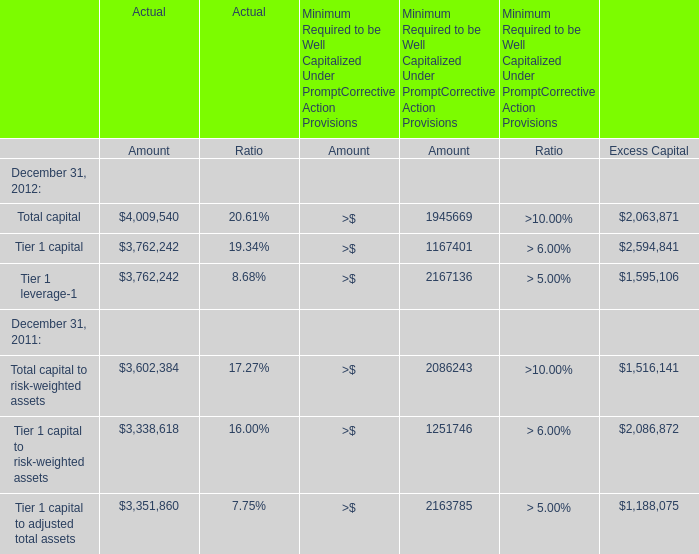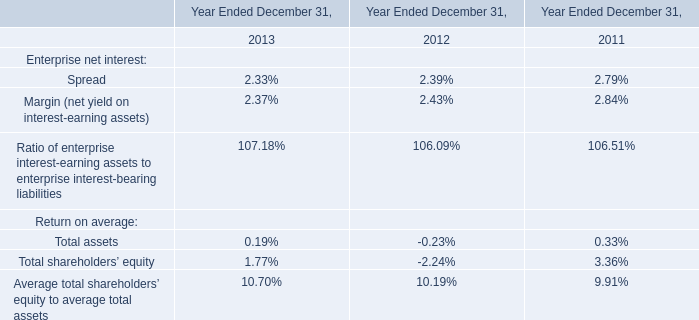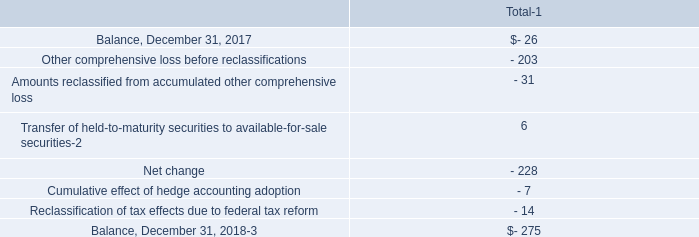What is the growing rate of Total capital in the year with the most Total capital? 
Computations: ((4009540 - 3602384) / 3602384)
Answer: 0.11302. 